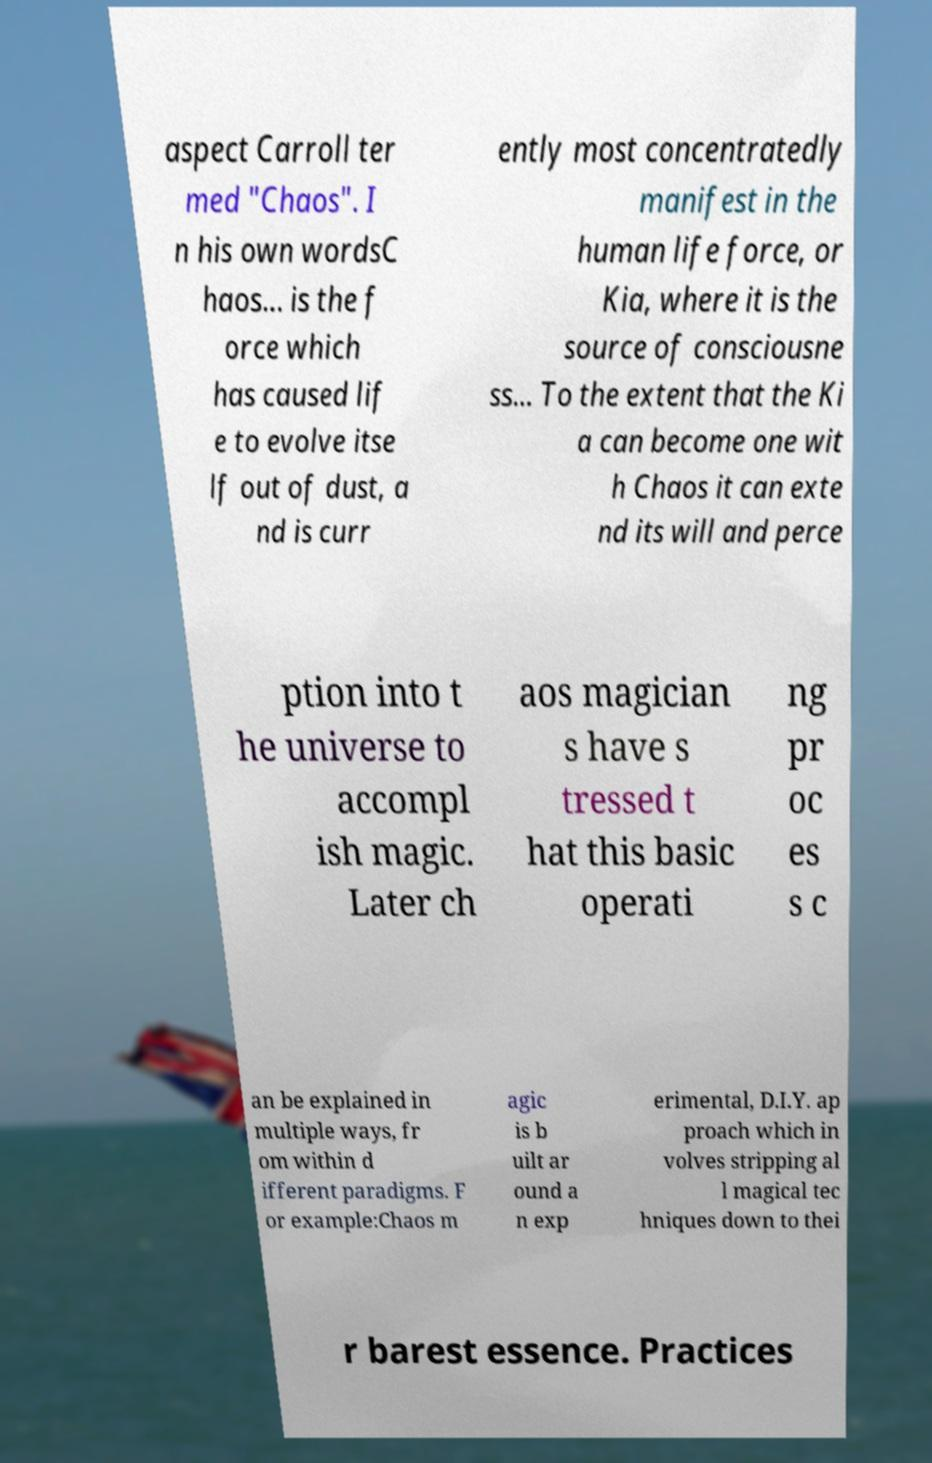Can you read and provide the text displayed in the image?This photo seems to have some interesting text. Can you extract and type it out for me? aspect Carroll ter med "Chaos". I n his own wordsC haos... is the f orce which has caused lif e to evolve itse lf out of dust, a nd is curr ently most concentratedly manifest in the human life force, or Kia, where it is the source of consciousne ss... To the extent that the Ki a can become one wit h Chaos it can exte nd its will and perce ption into t he universe to accompl ish magic. Later ch aos magician s have s tressed t hat this basic operati ng pr oc es s c an be explained in multiple ways, fr om within d ifferent paradigms. F or example:Chaos m agic is b uilt ar ound a n exp erimental, D.I.Y. ap proach which in volves stripping al l magical tec hniques down to thei r barest essence. Practices 